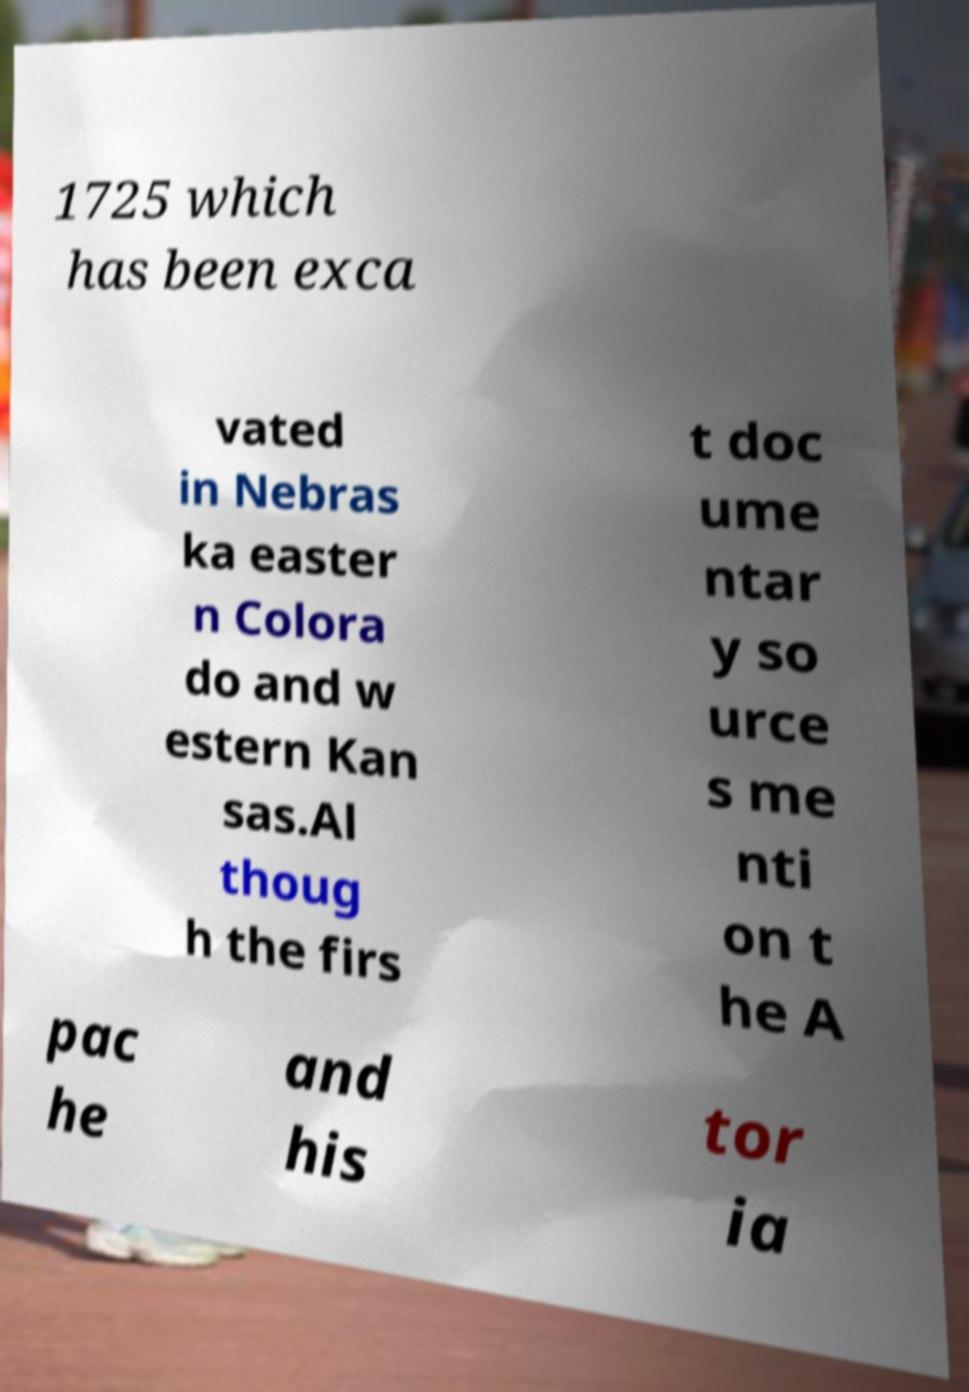I need the written content from this picture converted into text. Can you do that? 1725 which has been exca vated in Nebras ka easter n Colora do and w estern Kan sas.Al thoug h the firs t doc ume ntar y so urce s me nti on t he A pac he and his tor ia 